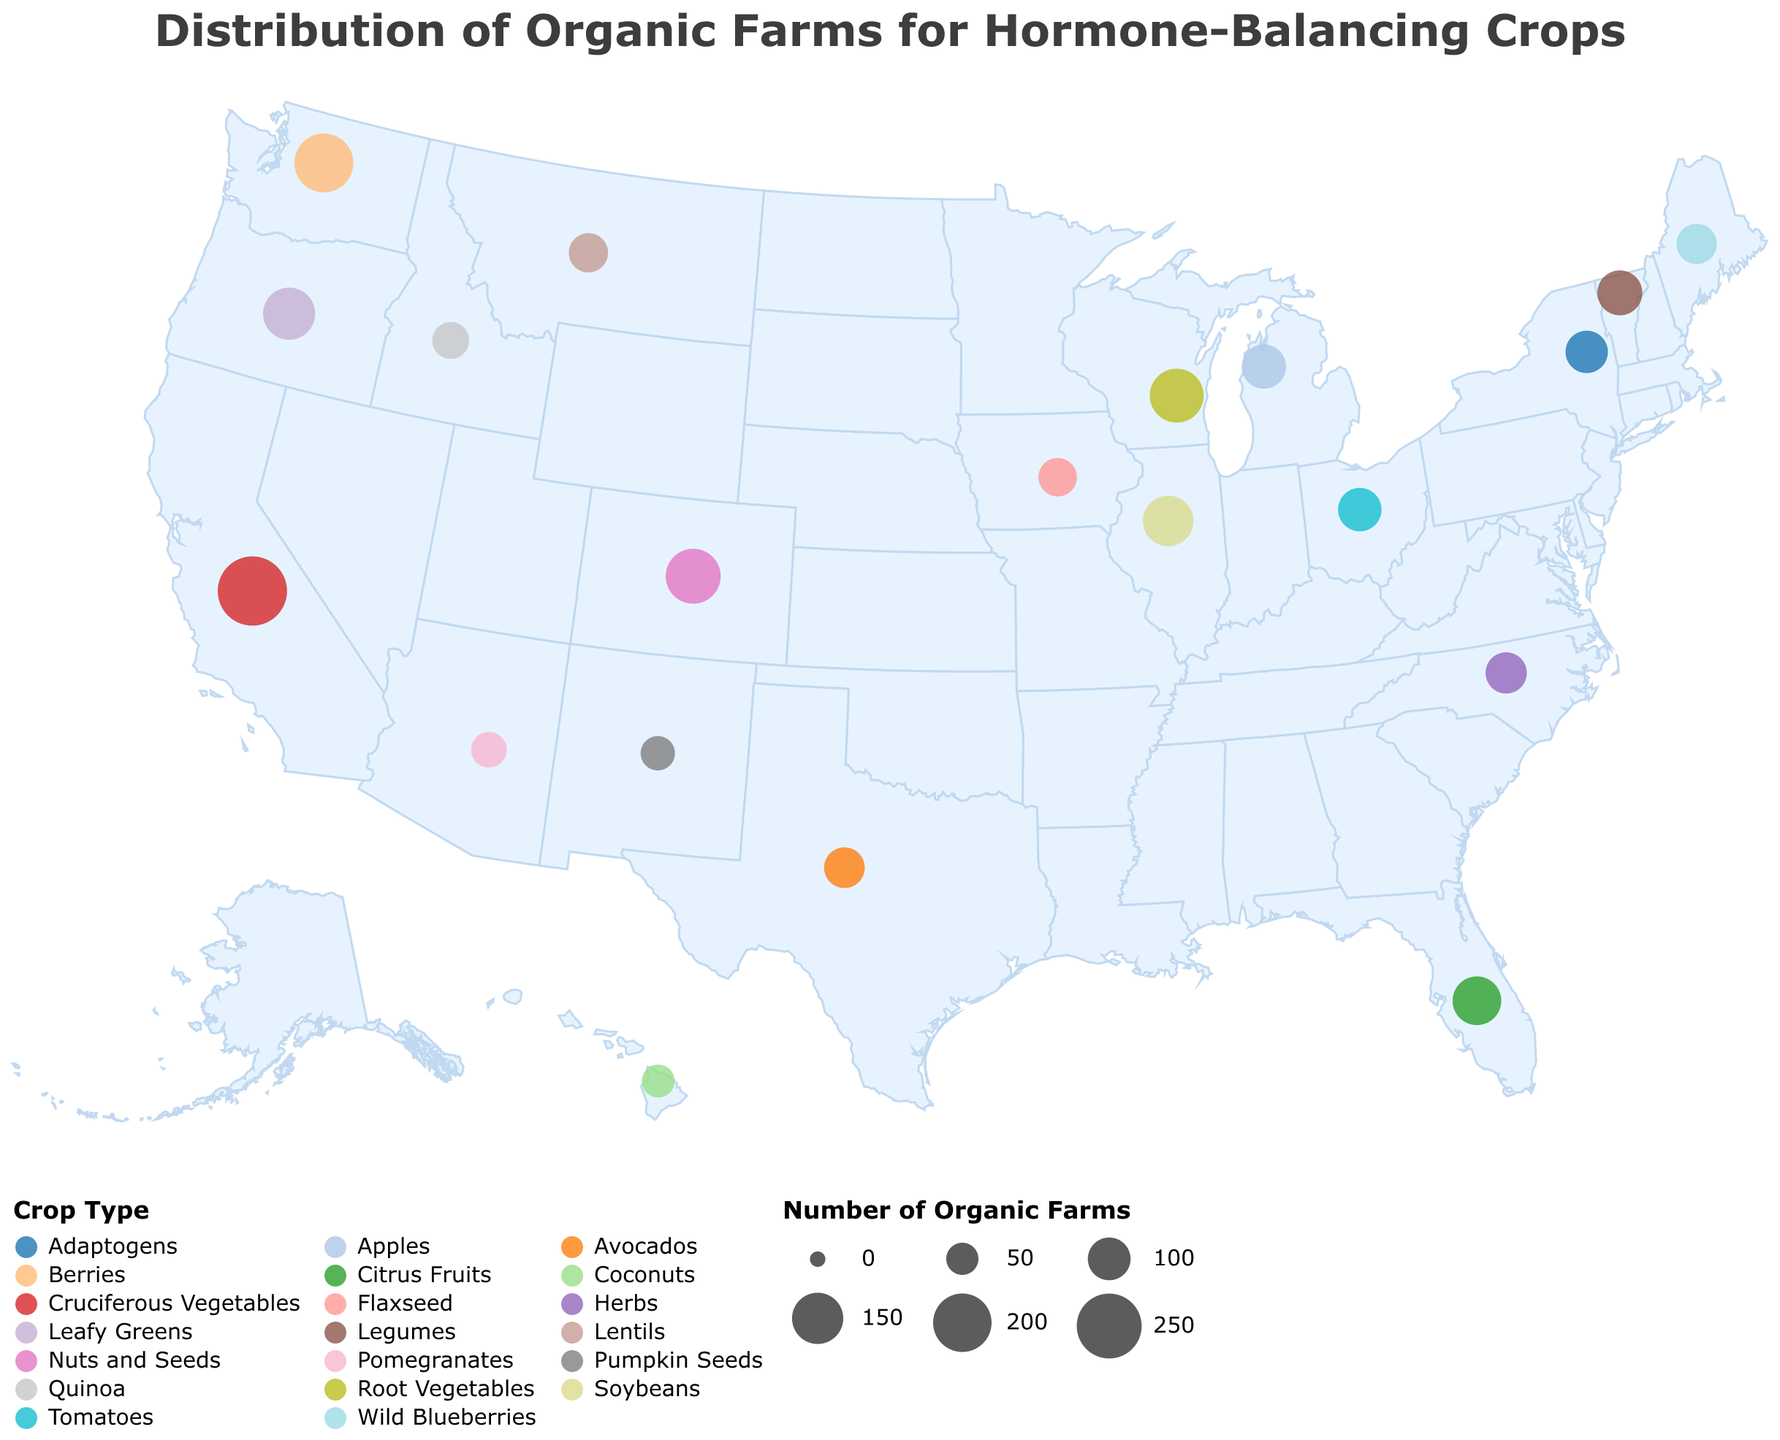Which region has the highest number of organic farms for hormone-balancing crops? Looking at the size of the circles, California stands out with the largest circle. According to the tooltip, California has 287 organic farms.
Answer: California Which crop type is most common among the hormone-balancing farms in the U.S.? To identify the most common crop type, we need to compare the number of farms for each crop. Cruciferous Vegetables in California have the highest number (287 farms).
Answer: Cruciferous Vegetables How many states have more than 100 organic farms? Count the circles with a size representing more than 100 organic farms. There are California (287), Oregon (156), Washington (203), Colorado (175), Illinois (146), Florida (134), Wisconsin (168), and Ohio (104). These are 8 states.
Answer: 8 Which region has the lowest number of organic farms for hormone-balancing crops? To find the region with the lowest number, look for the smallest circle. According to the tooltip, Hawaii has the smallest circle with 53 organic farms.
Answer: Hawaii Compare the number of organic farms in Colorado and Oregon. Which one has more? By comparing the circle sizes and referring to the tooltip, Colorado has 175 farms and Oregon has 156 farms. Thus, Colorado has more organic farms.
Answer: Colorado What is the total number of organic farms for hormone-balancing crops in the top three states? Identify the top three states with the most farms: California (287), Washington (203), and Colorado (175). Sum these values: 287 + 203 + 175 = 665.
Answer: 665 Which region specializes in berry farms? Look for the crop type labeled "Berries." According to the tooltip, Washington specializes in berries.
Answer: Washington Are there more organic farms for leafy greens or for legumes? Compare the circle sizes and tooltip information for leafy greens (Oregon, 156 farms) and legumes (Vermont, 112 farms). Leafy greens have more farms.
Answer: Leafy Greens How many regions produce hormone-balancing adaptogens organically? Identify the crop type labeled "Adaptogens." According to the tooltip, only New York produces adaptogens with 98 farms.
Answer: 1 Which region has more farms for hormone-balancing crops: Michigan or North Carolina? Compare the circle sizes and tooltip information for Michigan (109 farms) and North Carolina (92 farms). Michigan has more farms.
Answer: Michigan 